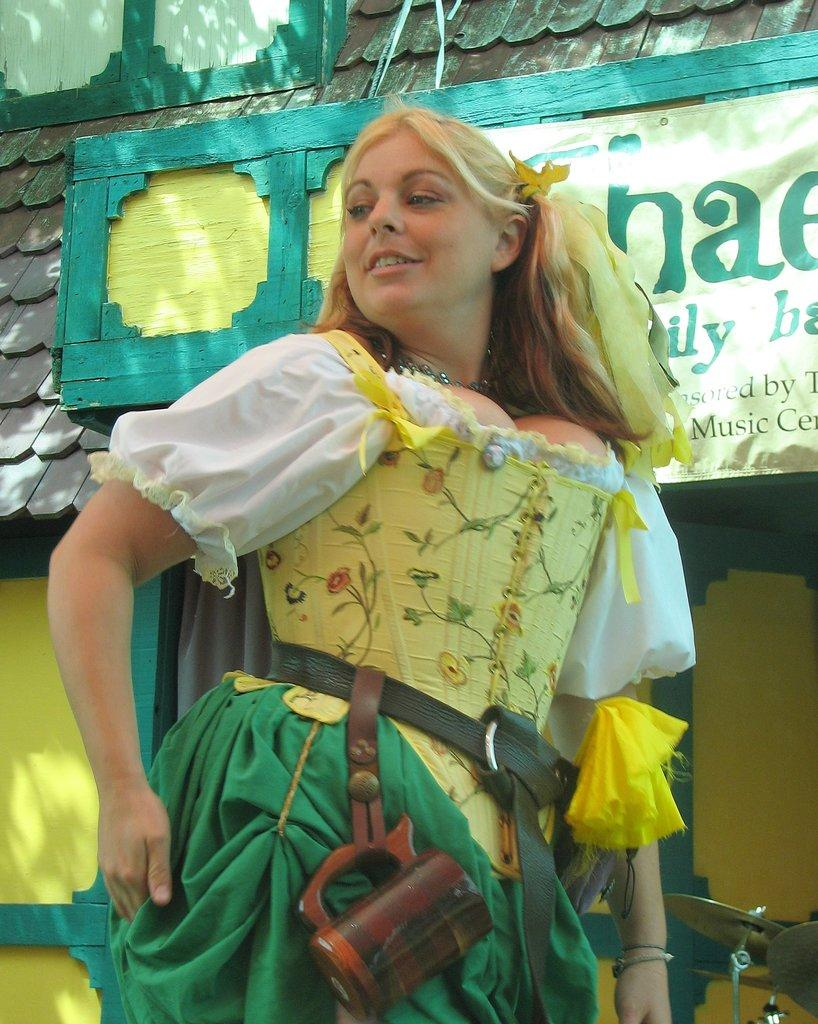Who is present in the image? There is a lady in the image. What is the lady holding or wearing? The lady has a cup hanging from her belt. What can be seen on the board in the image? There is text on the board in the image. Where is the board located in relation to the house? The board is located at the front part of a house. What type of object is related to music in the image? There is a musical instrument in the image. What channel is the lady watching on the television in the image? There is no television present in the image, so it is not possible to determine what channel the lady might be watching. 